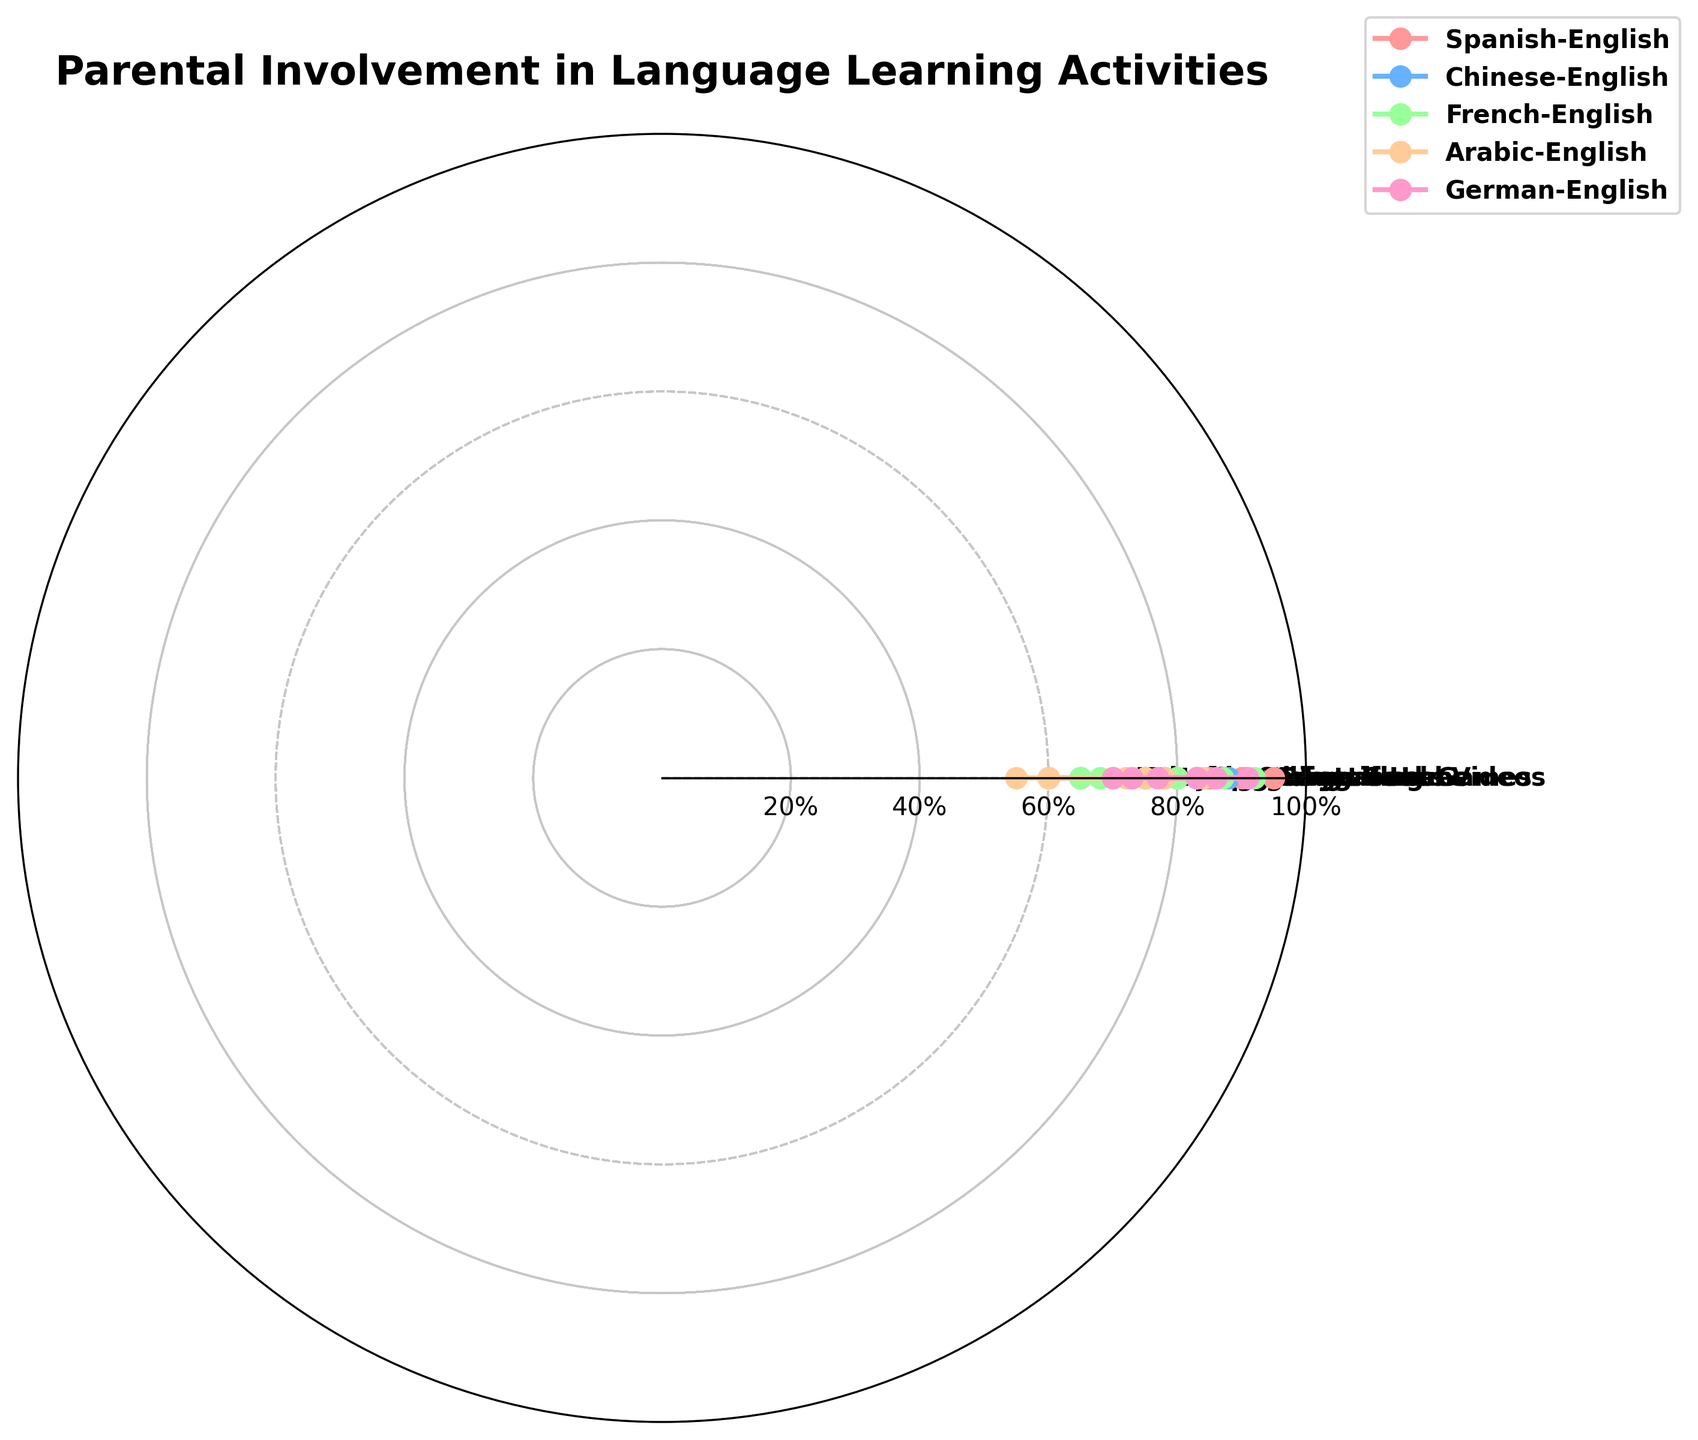Which bilingual household shows the highest parental involvement in reading books? Check the radar chart's radial lines for each category. The peak for "Reading Books" is seen at the Spanish-English household.
Answer: Spanish-English Which category has the lowest parental involvement across all bilingual households? Examine the outermost points for each category. The shortest distance from the center is seen for "Language Classes".
Answer: Language Classes How much greater is the involvement in storytelling for the Arabic-English household compared to Chinese-English? Find the angle for "Storytelling" and note the corresponding values for Arabic-English and Chinese-English. Subtract the value of Chinese-English from Arabic-English: 78 - 83 = -5.
Answer: -5 What is the average parental involvement in speaking at home across all bilingual households? Sum the values for "Speaking at Home" from all households and divide by 5: (95 + 88 + 92 + 84 + 91) / 5 = 90.
Answer: 90 Which bilingual category has the smallest range of involvement values across all activities? Calculate the range (max - min) for each category, then find the smallest: 
- Spanish-English: 95 - 60 = 35
- Chinese-English: 88 - 65 = 23
- French-English: 92 - 65 = 27
- Arabic-English: 84 - 55 = 29
- German-English: 91 - 70 = 21
German-English has the smallest range.
Answer: German-English In which category do the French-English households exhibit the highest parental involvement? Identify the highest point on the radar chart for the French-English household. "Speaking at Home" shows the highest involvement at 92.
Answer: Speaking at Home Which bilingual household has the least involvement in watching educational videos? Check the radial points for "Watching Educational Videos" and find the lowest. It is the Arabic-English household at 60.
Answer: Arabic-English Do all bilingual households have more involvement in storytelling than in playing educational games? Compare the values for "Storytelling" and "Playing Educational Games" for each household:
- Spanish-English: 90 > 75
- Chinese-English: 83 > 80
- French-English: 87 > 70
- Arabic-English: 78 > 72
- German-English: 86 > 77
All comparisons show higher values for "Storytelling".
Answer: Yes 